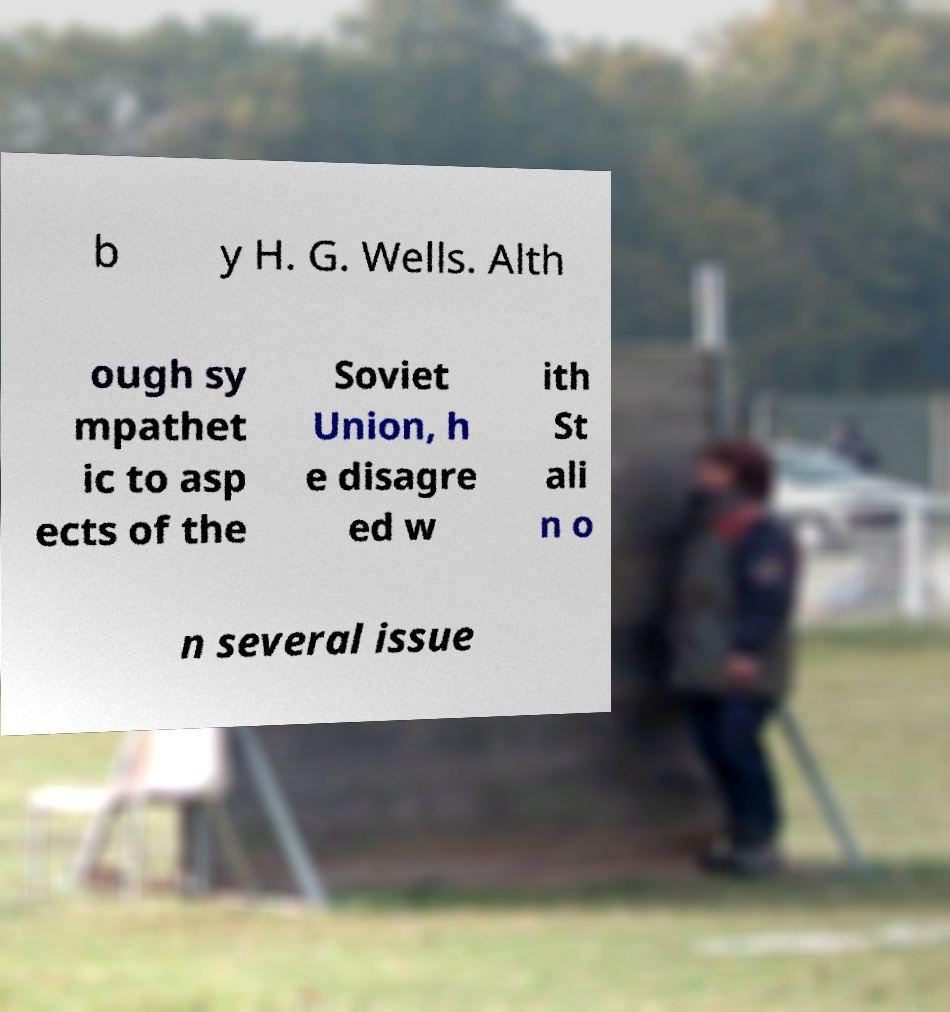Can you accurately transcribe the text from the provided image for me? b y H. G. Wells. Alth ough sy mpathet ic to asp ects of the Soviet Union, h e disagre ed w ith St ali n o n several issue 